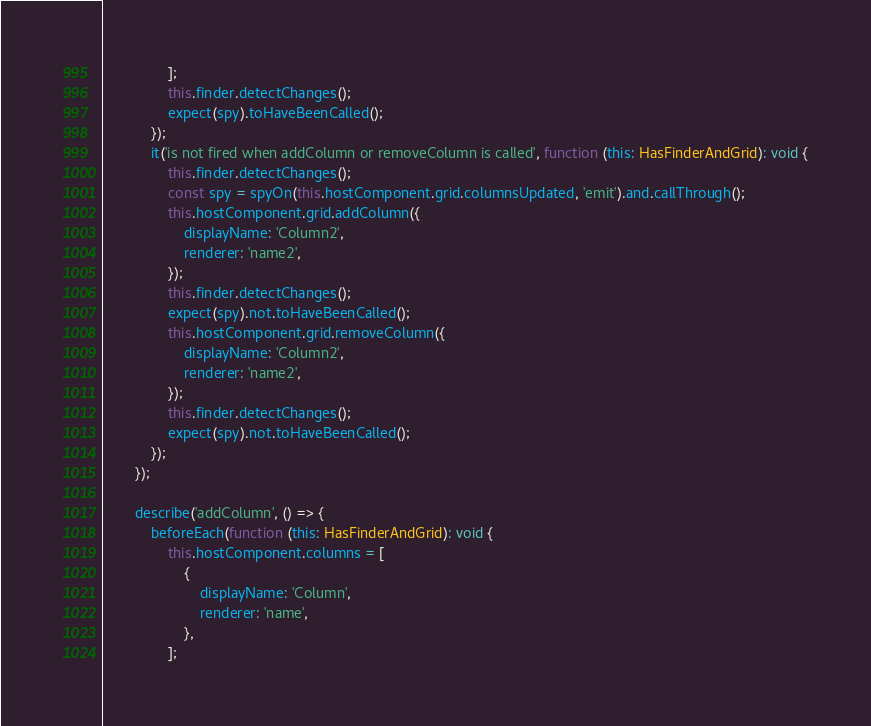Convert code to text. <code><loc_0><loc_0><loc_500><loc_500><_TypeScript_>                ];
                this.finder.detectChanges();
                expect(spy).toHaveBeenCalled();
            });
            it('is not fired when addColumn or removeColumn is called', function (this: HasFinderAndGrid): void {
                this.finder.detectChanges();
                const spy = spyOn(this.hostComponent.grid.columnsUpdated, 'emit').and.callThrough();
                this.hostComponent.grid.addColumn({
                    displayName: 'Column2',
                    renderer: 'name2',
                });
                this.finder.detectChanges();
                expect(spy).not.toHaveBeenCalled();
                this.hostComponent.grid.removeColumn({
                    displayName: 'Column2',
                    renderer: 'name2',
                });
                this.finder.detectChanges();
                expect(spy).not.toHaveBeenCalled();
            });
        });

        describe('addColumn', () => {
            beforeEach(function (this: HasFinderAndGrid): void {
                this.hostComponent.columns = [
                    {
                        displayName: 'Column',
                        renderer: 'name',
                    },
                ];</code> 